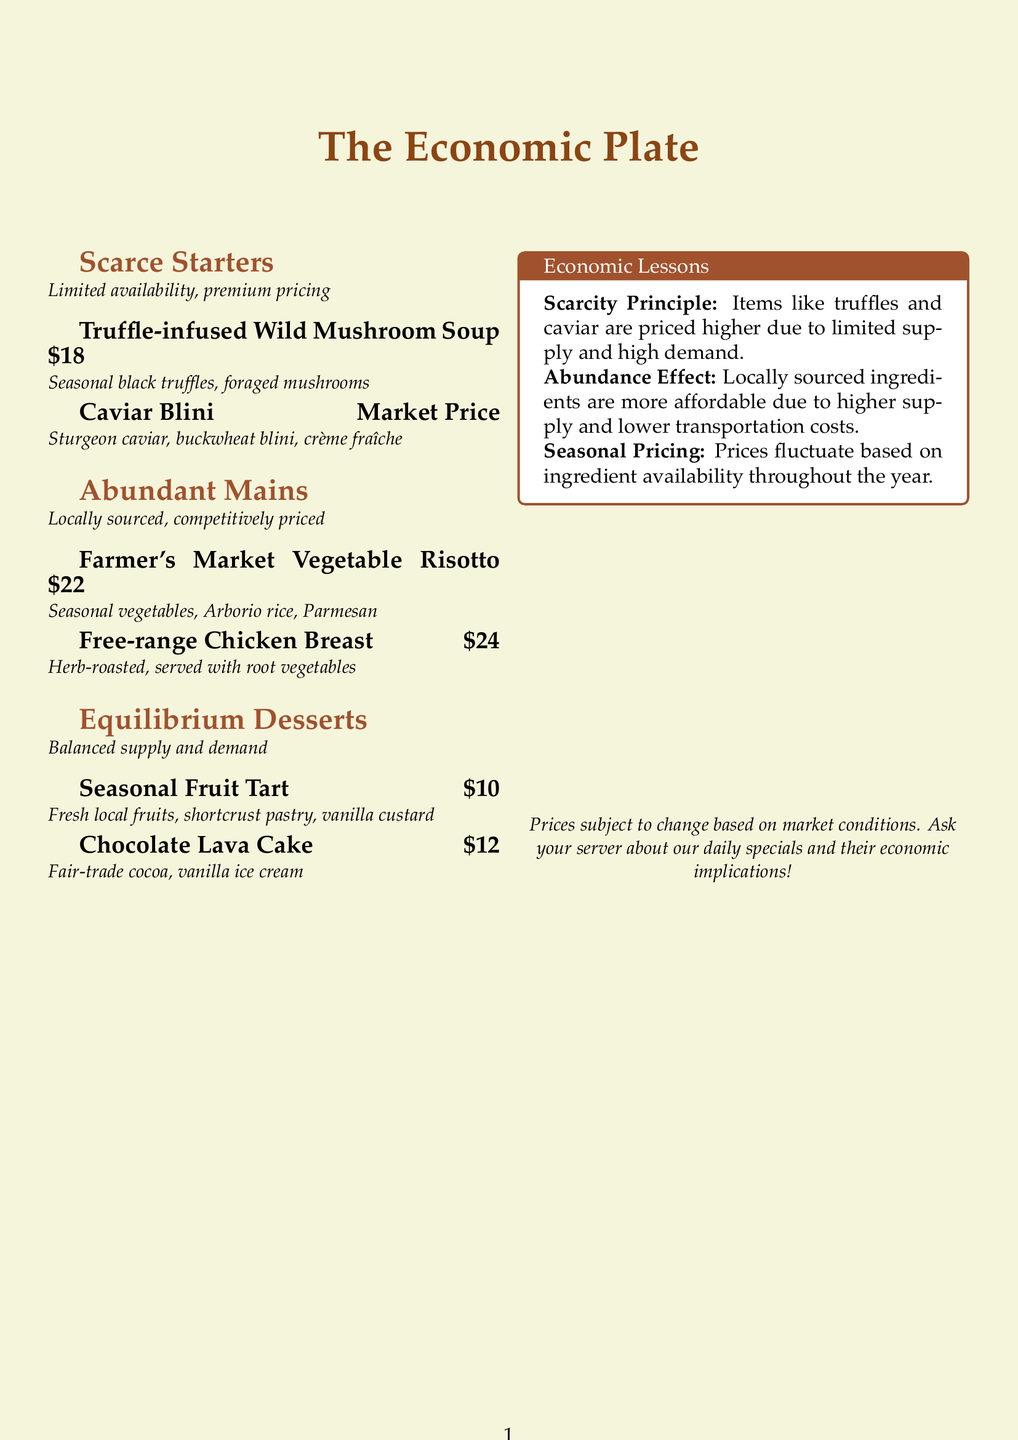What is the price of the Truffle-infused Wild Mushroom Soup? The price is explicitly stated next to the menu item in the document.
Answer: $18 What is the market price for the Caviar Blini? The menu lists the Caviar Blini's price as "Market Price," indicating that it can vary.
Answer: Market Price What is a main dish that uses seasonal vegetables? The document specifies a dish that prominently features seasonal vegetables in its description.
Answer: Farmer's Market Vegetable Risotto What is the price of the Chocolate Lava Cake? This information is directly detailed in the dessert section of the menu.
Answer: $12 What economic principle is illustrated with items like truffles and caviar? The text mentions the specific principle associated with limited supply and high demand.
Answer: Scarcity Principle How much is the Free-range Chicken Breast? The document provides the price for this specific main dish.
Answer: $24 What type of desserts does the menu categorize under equilibrium? The menu uses this term to describe a balanced relationship concerning supply and demand for desserts.
Answer: Equilibrium Desserts Which dessert includes fresh local fruits? The document highlights a dessert that features fresh local fruits specifically in its description.
Answer: Seasonal Fruit Tart What pricing strategy is mentioned regarding seasonal ingredients? The document discusses how prices change due to availability over time.
Answer: Seasonal Pricing 